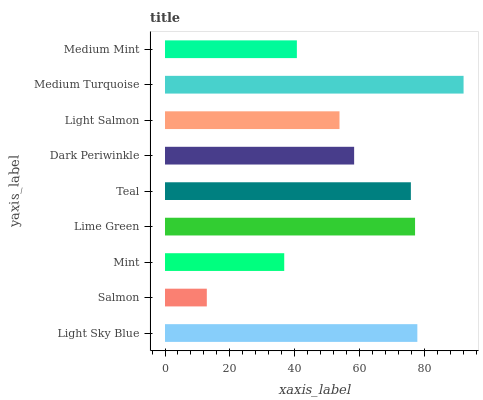Is Salmon the minimum?
Answer yes or no. Yes. Is Medium Turquoise the maximum?
Answer yes or no. Yes. Is Mint the minimum?
Answer yes or no. No. Is Mint the maximum?
Answer yes or no. No. Is Mint greater than Salmon?
Answer yes or no. Yes. Is Salmon less than Mint?
Answer yes or no. Yes. Is Salmon greater than Mint?
Answer yes or no. No. Is Mint less than Salmon?
Answer yes or no. No. Is Dark Periwinkle the high median?
Answer yes or no. Yes. Is Dark Periwinkle the low median?
Answer yes or no. Yes. Is Lime Green the high median?
Answer yes or no. No. Is Light Sky Blue the low median?
Answer yes or no. No. 